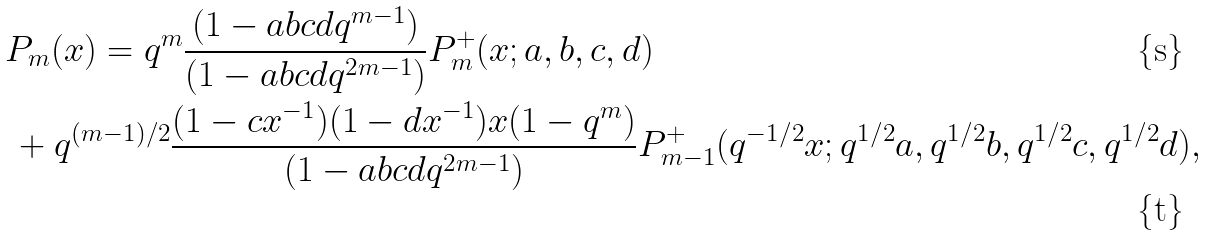Convert formula to latex. <formula><loc_0><loc_0><loc_500><loc_500>& P _ { m } ( x ) = q ^ { m } \frac { ( 1 - a b c d q ^ { m - 1 } ) } { ( 1 - a b c d q ^ { 2 m - 1 } ) } P _ { m } ^ { + } ( x ; a , b , c , d ) \\ & \, + q ^ { ( m - 1 ) / 2 } \frac { ( 1 - c x ^ { - 1 } ) ( 1 - d x ^ { - 1 } ) x ( 1 - q ^ { m } ) } { ( 1 - a b c d q ^ { 2 m - 1 } ) } P _ { m - 1 } ^ { + } ( q ^ { - 1 / 2 } x ; q ^ { 1 / 2 } a , q ^ { 1 / 2 } b , q ^ { 1 / 2 } c , q ^ { 1 / 2 } d ) ,</formula> 